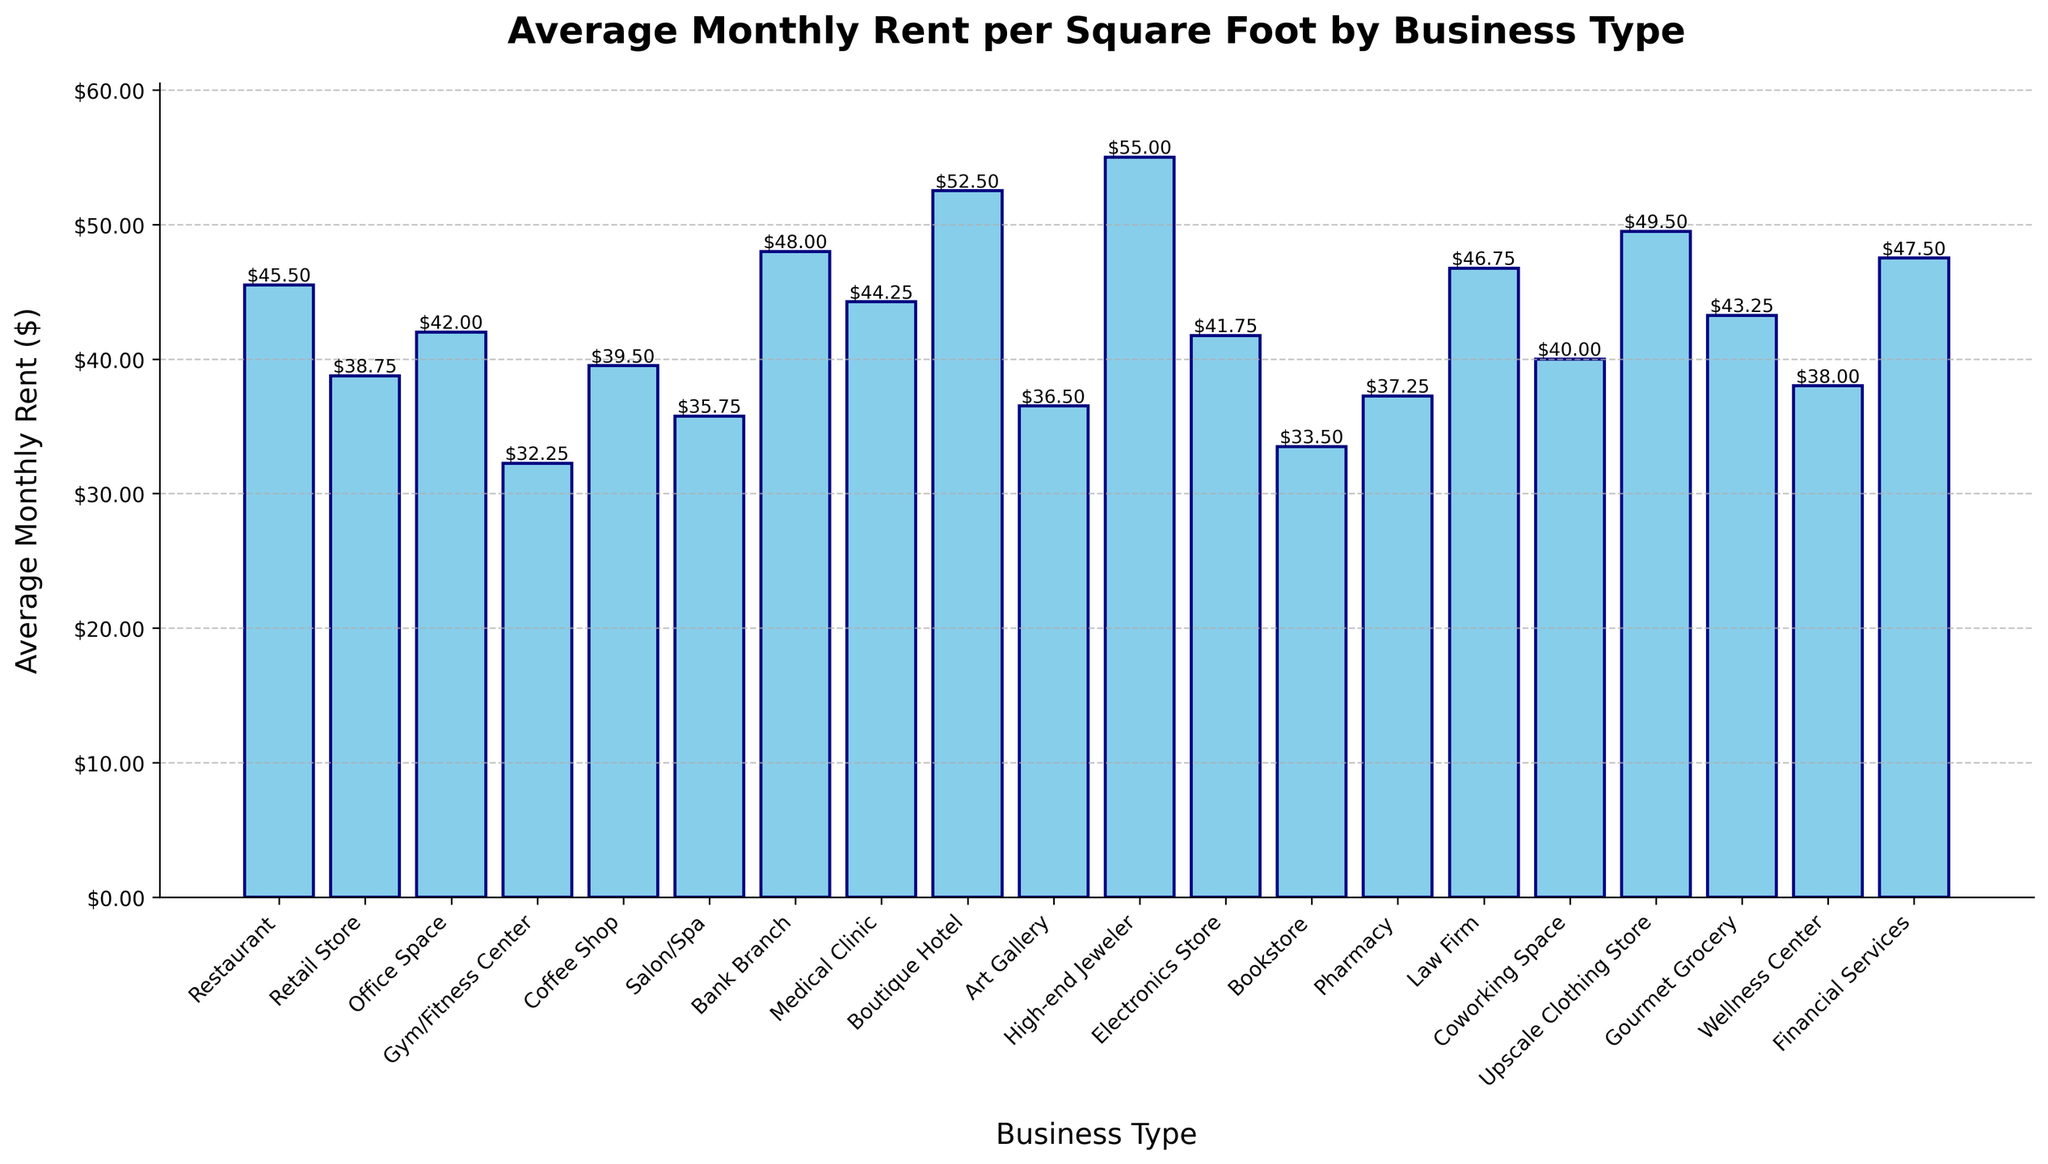What business type has the highest average monthly rent per square foot? By visually inspecting the height of the bars, the tallest bar indicates the highest rent. The "High-end Jeweler" bar is the tallest among all.
Answer: High-end Jeweler Which business type has the lowest average monthly rent per square foot? By looking at the shortest bar in the chart, the "Gym/Fitness Center" bar is the shortest one, indicating the lowest rent.
Answer: Gym/Fitness Center How much more is the average monthly rent for a "High-end Jeweler" compared to a "Bookstore"? Find the heights of the "High-end Jeweler" and "Bookstore" bars, and subtract the height of "Bookstore" from "High-end Jeweler". The rents are $55.00 and $33.50 respectively, so the difference is $55.00 - $33.50 = $21.50.
Answer: $21.50 What is the total combined rent for a "Restaurant" and "Coffee Shop"? Add the heights of the "Restaurant" and "Coffee Shop" bars. The rents are $45.50 and $39.50 respectively, so the total combined rent is $45.50 + $39.50 = $85.00.
Answer: $85.00 Are there more business types with rents above $40.00 or below $40.00? Count the bars that are above $40.00 and those below $40.00. Bars above $40.00: Restaurant, Office Space, Coffee Shop, Medical Clinic, Bank Branch, Law Firm, Upscale Clothing Store, Financial Services, Gourmet Grocery, High-end Jeweler, Electronics Store (11). Bars below $40.00: Retail Store, Gym/Fitness Center, Salon/Spa, Art Gallery, Bookstore, Pharmacy, Wellness Center (7). There are more business types with rents above $40.00.
Answer: Above $40.00 Which business type has a rent closest to $40.00 and what is that rent? Visually inspect the bars near the $40.00 mark. "Coworking Space" has a rent of $40.00 exactly.
Answer: Coworking Space, $40.00 What is the difference in rent between a "Bank Branch" and an "Office Space"? Find the heights of the "Bank Branch" and "Office Space" bars and subtract the height of "Office Space" from "Bank Branch". The rents are $48.00 and $42.00 respectively, so the difference is $48.00 - $42.00 = $6.00.
Answer: $6.00 Which business types have rents higher than $50.00? Identify the bars with heights above the $50.00 mark. These are "Boutique Hotel" and "High-end Jeweler".
Answer: Boutique Hotel, High-end Jeweler What is the average rent for the business types "Retail Store", "Office Space", and "Coffee Shop"? Find the heights of the specified bars and calculate their average. The rents are $38.75 for "Retail Store", $42.00 for "Office Space", and $39.50 for "Coffee Shop". The average is ($38.75 + $42.00 + $39.50) / 3 = $40.75.
Answer: $40.75 